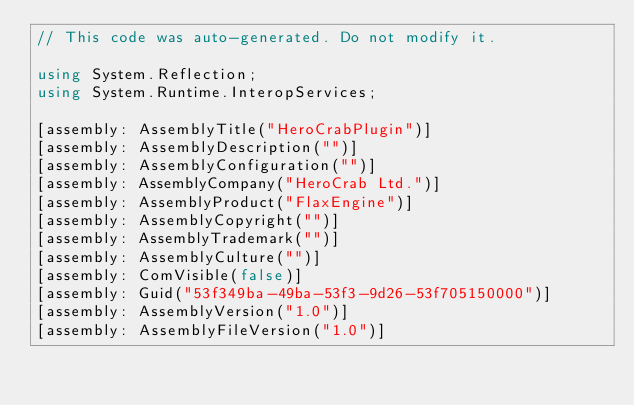<code> <loc_0><loc_0><loc_500><loc_500><_C#_>// This code was auto-generated. Do not modify it.

using System.Reflection;
using System.Runtime.InteropServices;

[assembly: AssemblyTitle("HeroCrabPlugin")]
[assembly: AssemblyDescription("")]
[assembly: AssemblyConfiguration("")]
[assembly: AssemblyCompany("HeroCrab Ltd.")]
[assembly: AssemblyProduct("FlaxEngine")]
[assembly: AssemblyCopyright("")]
[assembly: AssemblyTrademark("")]
[assembly: AssemblyCulture("")]
[assembly: ComVisible(false)]
[assembly: Guid("53f349ba-49ba-53f3-9d26-53f705150000")]
[assembly: AssemblyVersion("1.0")]
[assembly: AssemblyFileVersion("1.0")]
</code> 